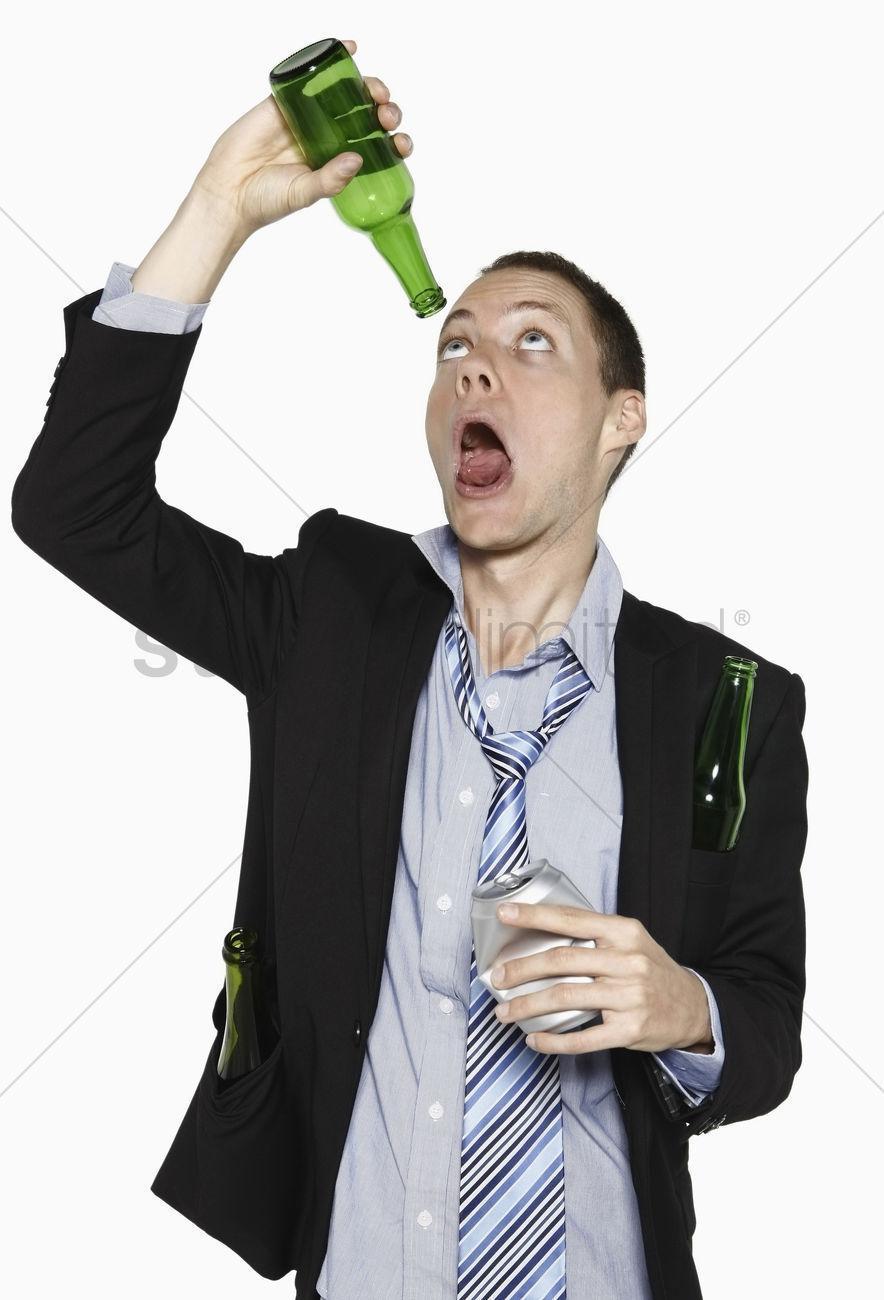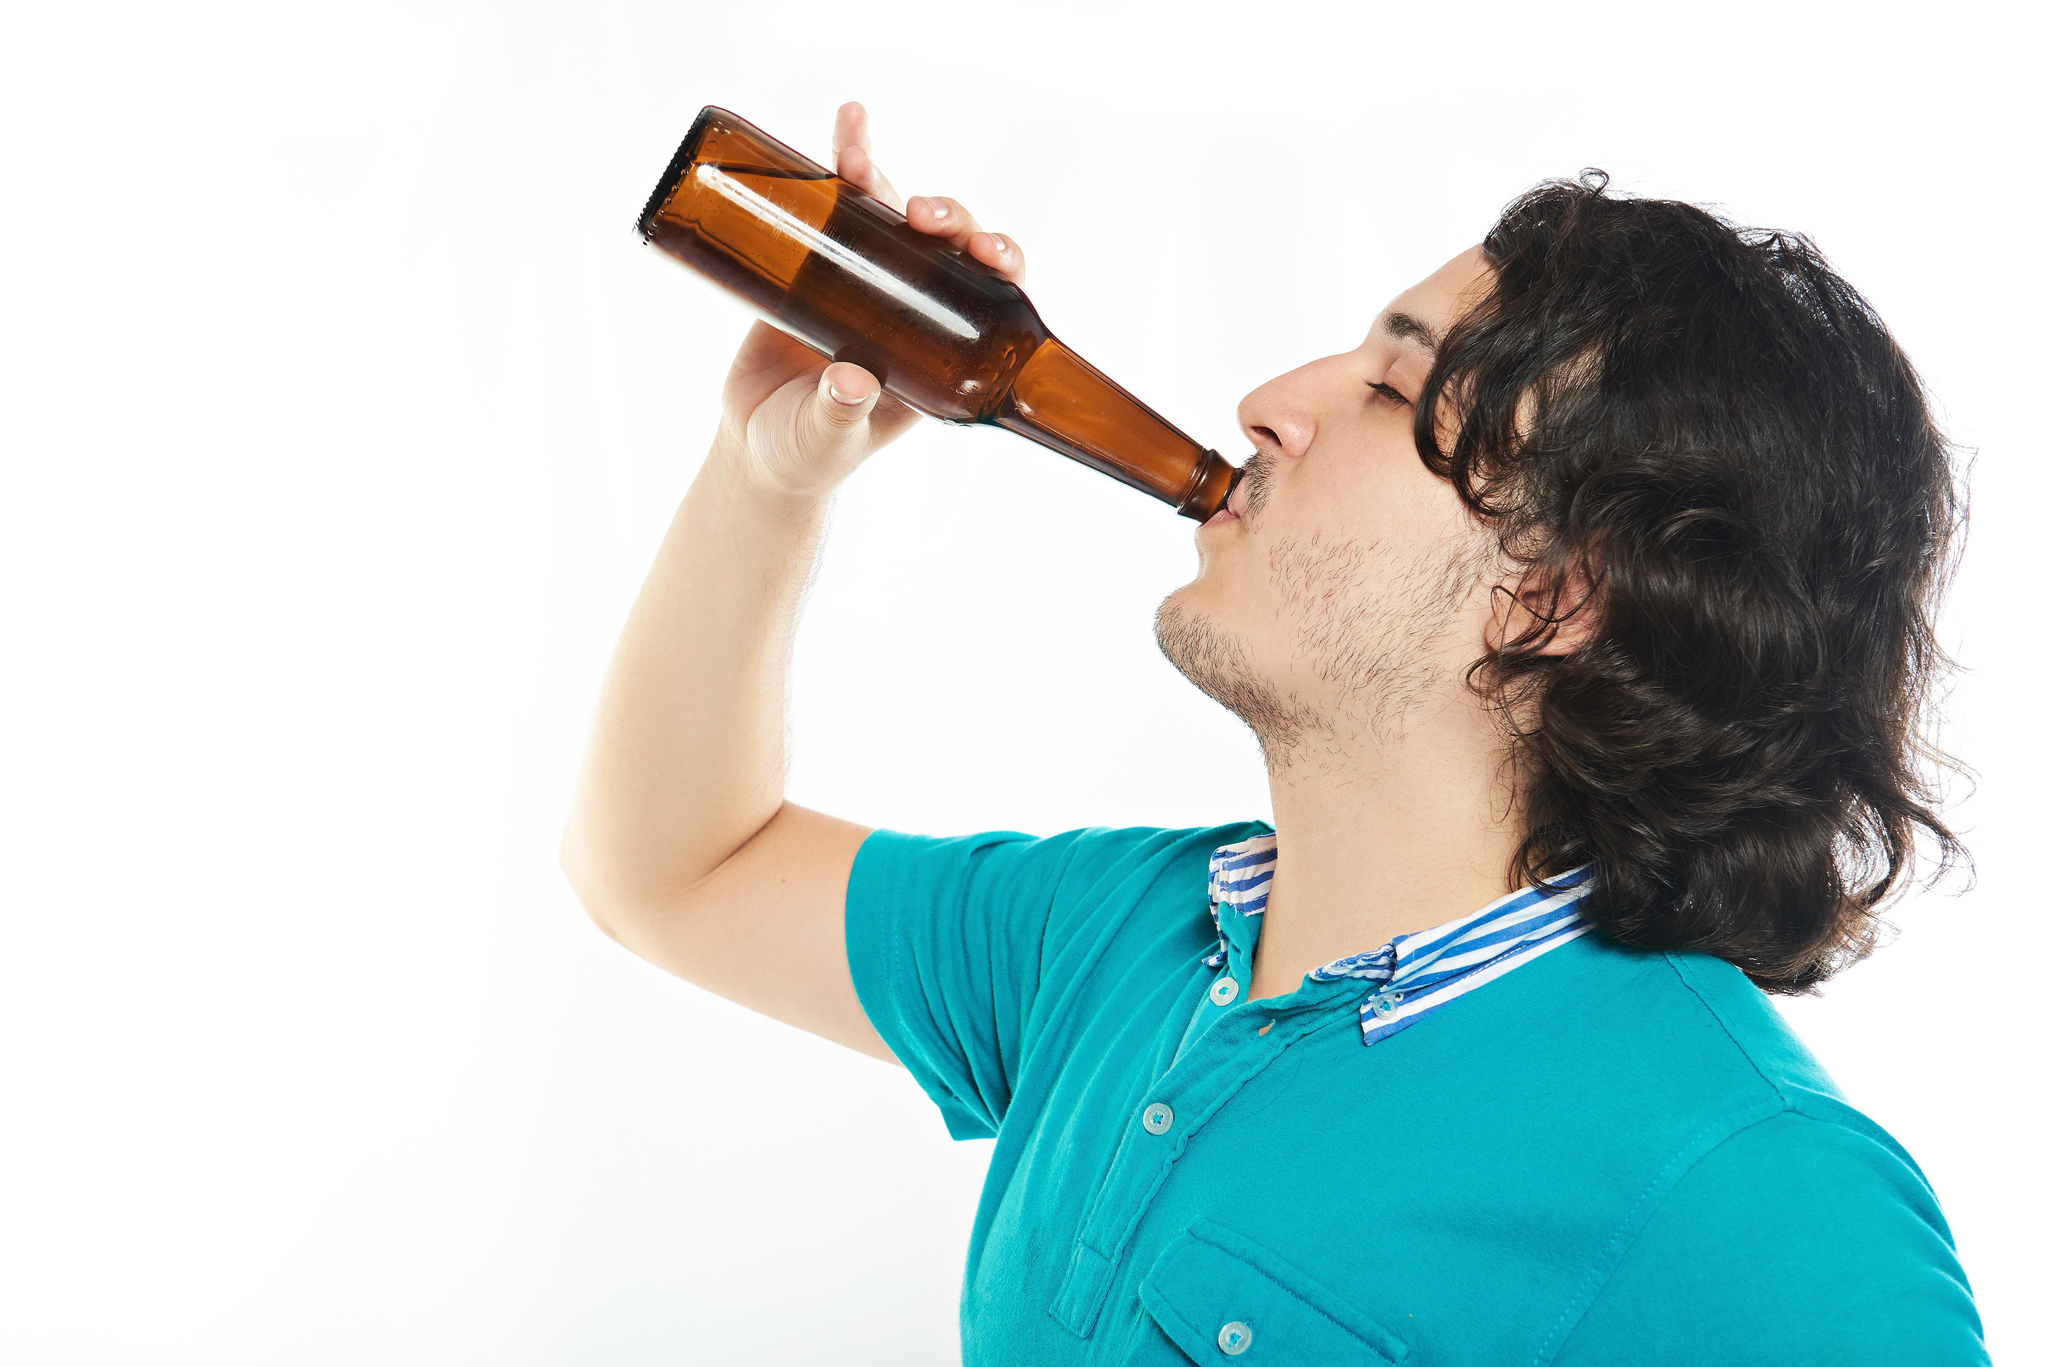The first image is the image on the left, the second image is the image on the right. Analyze the images presented: Is the assertion "The left and right image contains the same number of men standing drinking a single beer." valid? Answer yes or no. Yes. The first image is the image on the left, the second image is the image on the right. For the images shown, is this caption "One of these guys does not have a beer bottle at their lips." true? Answer yes or no. Yes. 